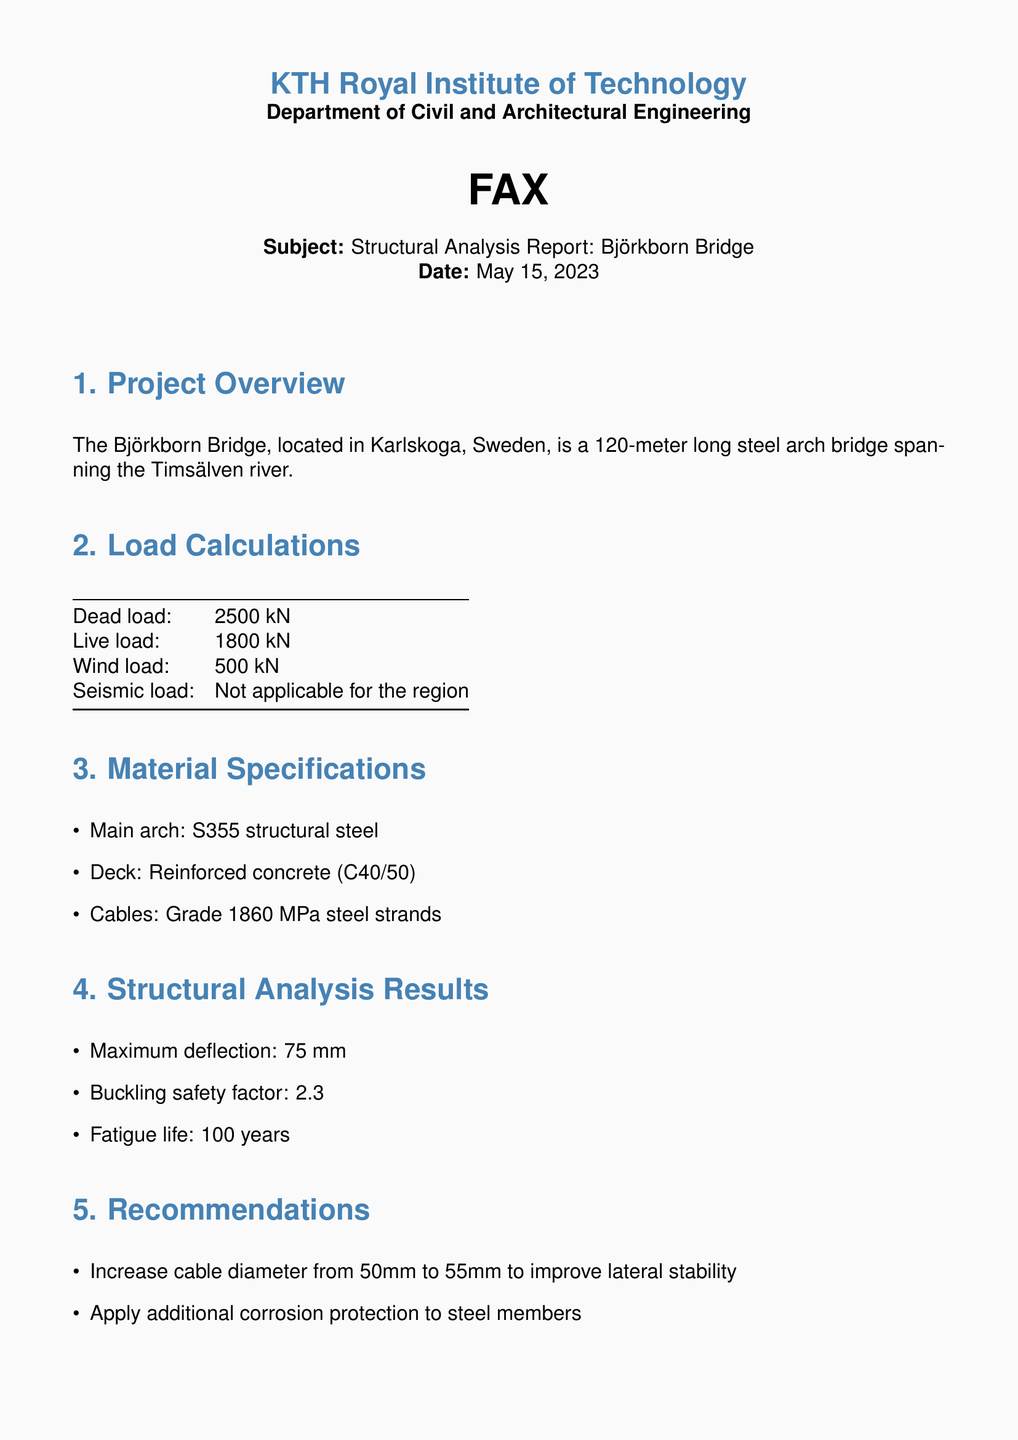What is the location of the Björkborn Bridge? The location is mentioned in the project overview section of the document.
Answer: Karlskoga, Sweden What is the live load on the bridge? The live load is provided in the load calculations section.
Answer: 1800 kN What type of steel is used for the main arch? The material specifications section specifies the type of steel used.
Answer: S355 structural steel What is the maximum deflection determined for the bridge? The maximum deflection is given in the structural analysis results section.
Answer: 75 mm What is the buckling safety factor for the bridge? This value is provided in the structural analysis results section.
Answer: 2.3 What diameter should the cable be increased to? The recommendation section suggests the new value for the cable diameter.
Answer: 55 mm What type of concrete is specified for the deck? The material specifications section indicates the concrete type.
Answer: C40/50 What is the predicted fatigue life of the bridge? The fatigue life is mentioned in the structural analysis results section.
Answer: 100 years What additional protection is recommended for the steel members? The recommendations section specifies the type of protection needed.
Answer: Corrosion protection 